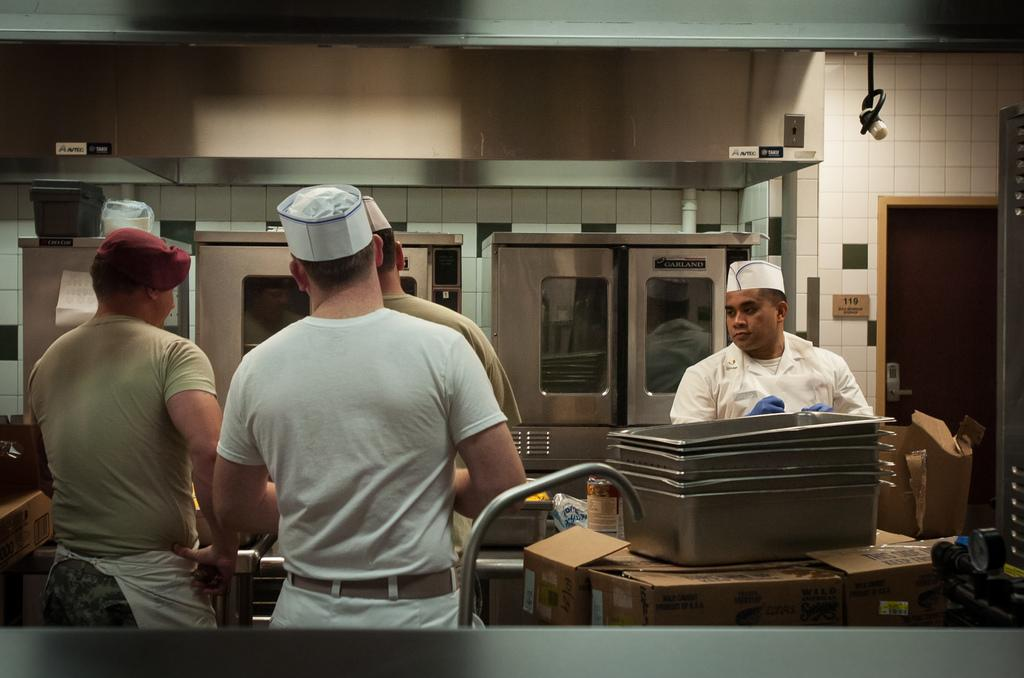How many men are in the image? There are four men standing in the image. What are the men wearing on their heads? The men are wearing caps. What can be seen in the background of the image? There is a wall, food containers, carton boxes, and other items visible in the background. What type of vein is visible on the men's arms in the image? There is no visible vein on the men's arms in the image. What type of army is depicted in the image? There is no army depicted in the image; it features four men standing together. 